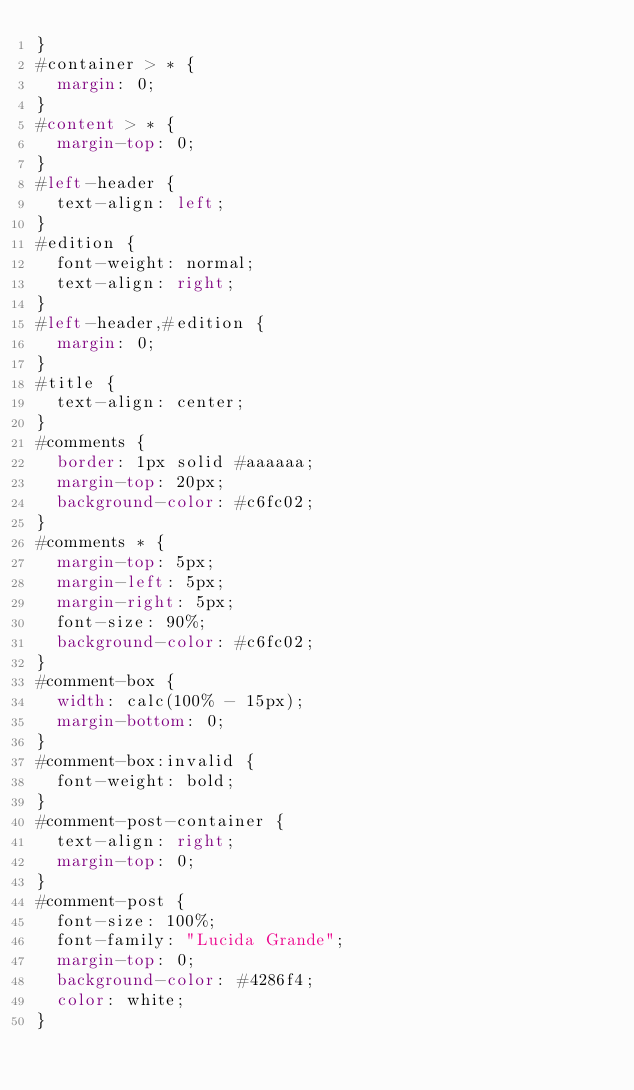Convert code to text. <code><loc_0><loc_0><loc_500><loc_500><_CSS_>}
#container > * {
  margin: 0;
}
#content > * {
  margin-top: 0;
}
#left-header {
  text-align: left;
}
#edition {
  font-weight: normal;
  text-align: right;
}
#left-header,#edition {
  margin: 0;
}
#title {
  text-align: center;
}
#comments {
  border: 1px solid #aaaaaa;
  margin-top: 20px;
  background-color: #c6fc02;
}
#comments * {
  margin-top: 5px;
  margin-left: 5px;
  margin-right: 5px;
  font-size: 90%;
  background-color: #c6fc02;
}
#comment-box {
  width: calc(100% - 15px);
  margin-bottom: 0;
}
#comment-box:invalid {
  font-weight: bold;
}
#comment-post-container {
  text-align: right;
  margin-top: 0;
}
#comment-post {
  font-size: 100%;
  font-family: "Lucida Grande";
  margin-top: 0;
  background-color: #4286f4;
  color: white;
}</code> 